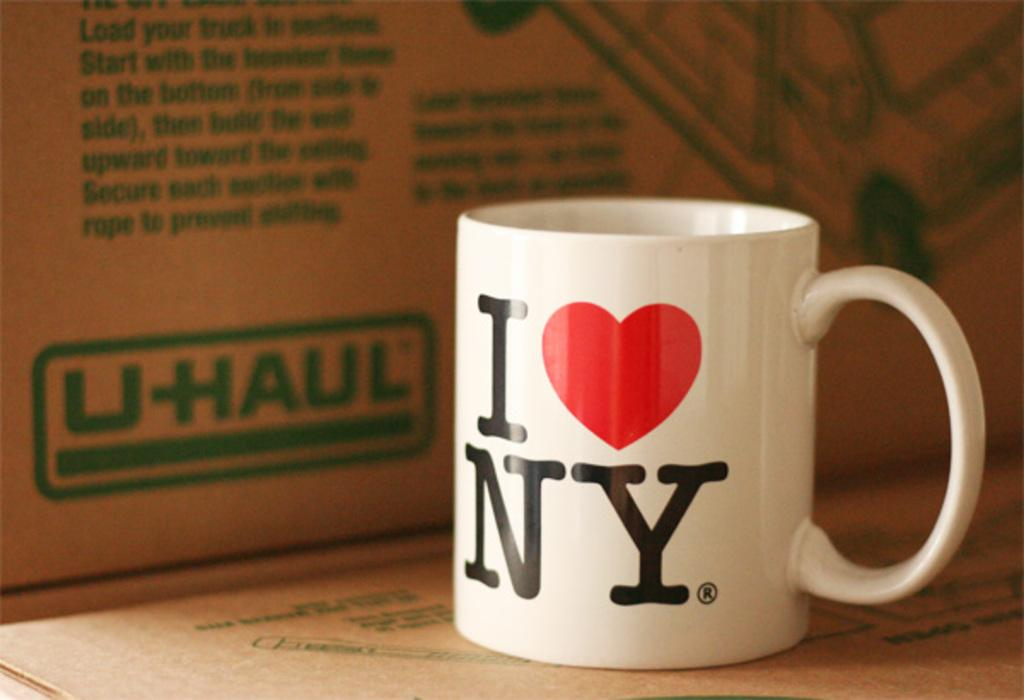<image>
Render a clear and concise summary of the photo. A white coffee cup that say I with a picture of a heart Ny next to a Uhaul box. 